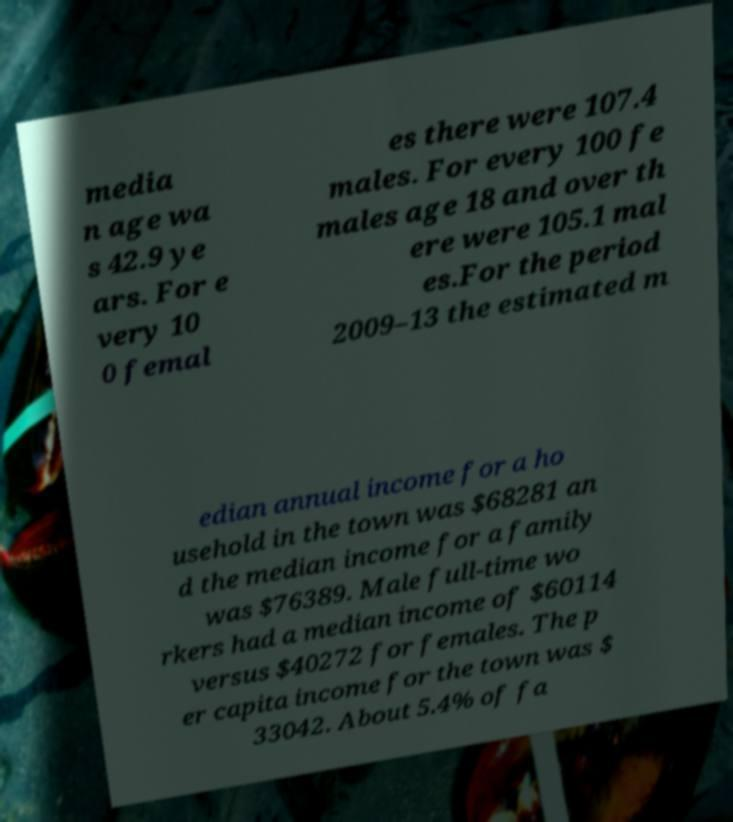For documentation purposes, I need the text within this image transcribed. Could you provide that? media n age wa s 42.9 ye ars. For e very 10 0 femal es there were 107.4 males. For every 100 fe males age 18 and over th ere were 105.1 mal es.For the period 2009–13 the estimated m edian annual income for a ho usehold in the town was $68281 an d the median income for a family was $76389. Male full-time wo rkers had a median income of $60114 versus $40272 for females. The p er capita income for the town was $ 33042. About 5.4% of fa 